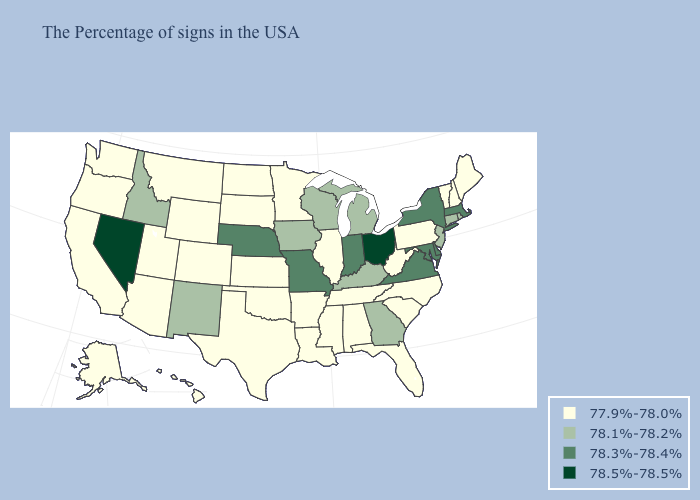What is the value of New Hampshire?
Be succinct. 77.9%-78.0%. Does Kansas have the lowest value in the USA?
Write a very short answer. Yes. Does Illinois have the highest value in the USA?
Concise answer only. No. What is the highest value in the USA?
Keep it brief. 78.5%-78.5%. Does Mississippi have the same value as New York?
Concise answer only. No. Name the states that have a value in the range 78.3%-78.4%?
Short answer required. Massachusetts, New York, Delaware, Maryland, Virginia, Indiana, Missouri, Nebraska. What is the highest value in states that border Virginia?
Give a very brief answer. 78.3%-78.4%. Name the states that have a value in the range 78.3%-78.4%?
Concise answer only. Massachusetts, New York, Delaware, Maryland, Virginia, Indiana, Missouri, Nebraska. Does Massachusetts have the lowest value in the USA?
Keep it brief. No. Does South Dakota have a higher value than New York?
Quick response, please. No. Which states hav the highest value in the Northeast?
Concise answer only. Massachusetts, New York. Does the map have missing data?
Keep it brief. No. Does Connecticut have a higher value than Louisiana?
Keep it brief. Yes. What is the lowest value in the USA?
Answer briefly. 77.9%-78.0%. 